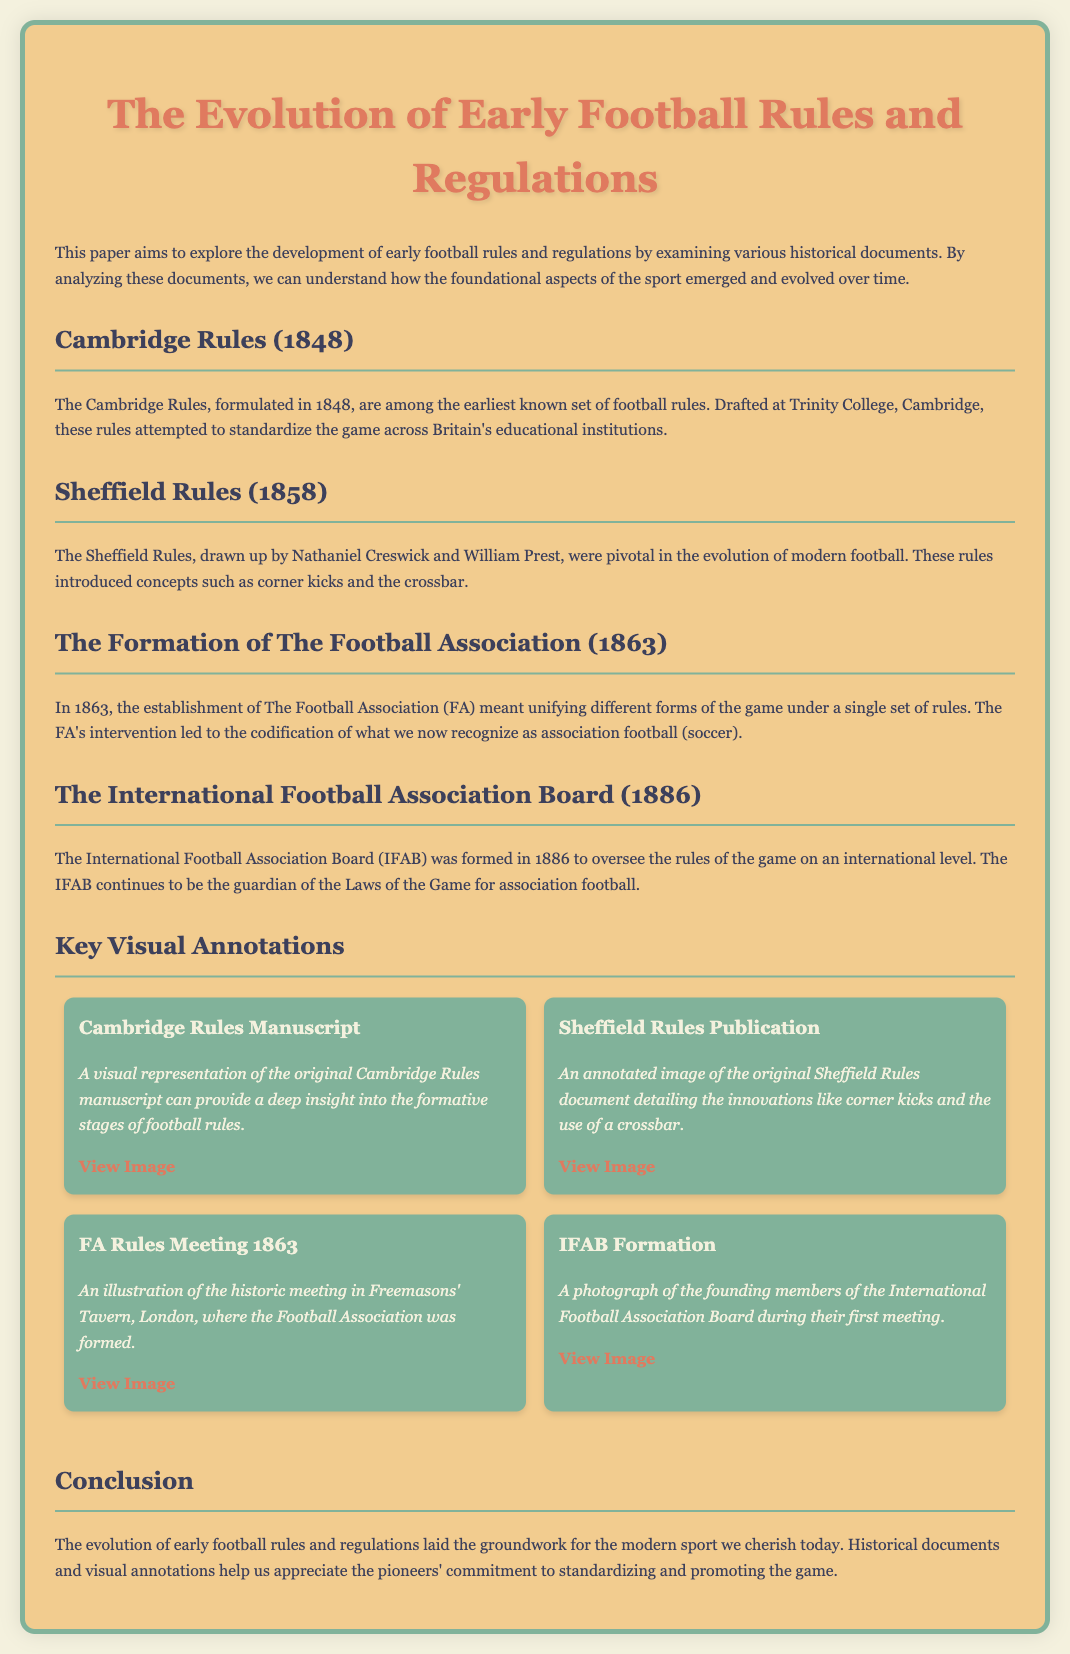What year were the Cambridge Rules formulated? The Cambridge Rules were officially documented in 1848, which is stated in the document.
Answer: 1848 Who drafted the Sheffield Rules? The document specifies that Nathaniel Creswick and William Prest were responsible for the Sheffield Rules.
Answer: Nathaniel Creswick and William Prest In what year was The Football Association established? The document indicates that The Football Association was formed in 1863.
Answer: 1863 What is the primary purpose of the International Football Association Board? The document mentions that the IFAB oversees the rules of the game on an international level.
Answer: Oversee the rules What innovative concepts did the Sheffield Rules introduce? The Sheffield Rules introduced concepts such as corner kicks and the crossbar, as highlighted in the text.
Answer: Corner kicks and crossbar What was the location of the FA's formation meeting? The FA's formation meeting took place at Freemasons' Tavern, London, as stated in the document.
Answer: Freemasons' Tavern, London What type of visuals are included in the document? The document mentions that there are annotated images of historical manuscripts and illustrations related to early football rules.
Answer: Annotated images How does the conclusion summarize the historical significance of early football rules? The conclusion emphasizes that the evolution of early football rules laid the groundwork for modern football.
Answer: Groundwork for modern football What visual representation is provided for the Cambridge Rules? A visual representation of the original Cambridge Rules manuscript is highlighted in the section on Cambridge Rules.
Answer: Original Cambridge Rules manuscript 